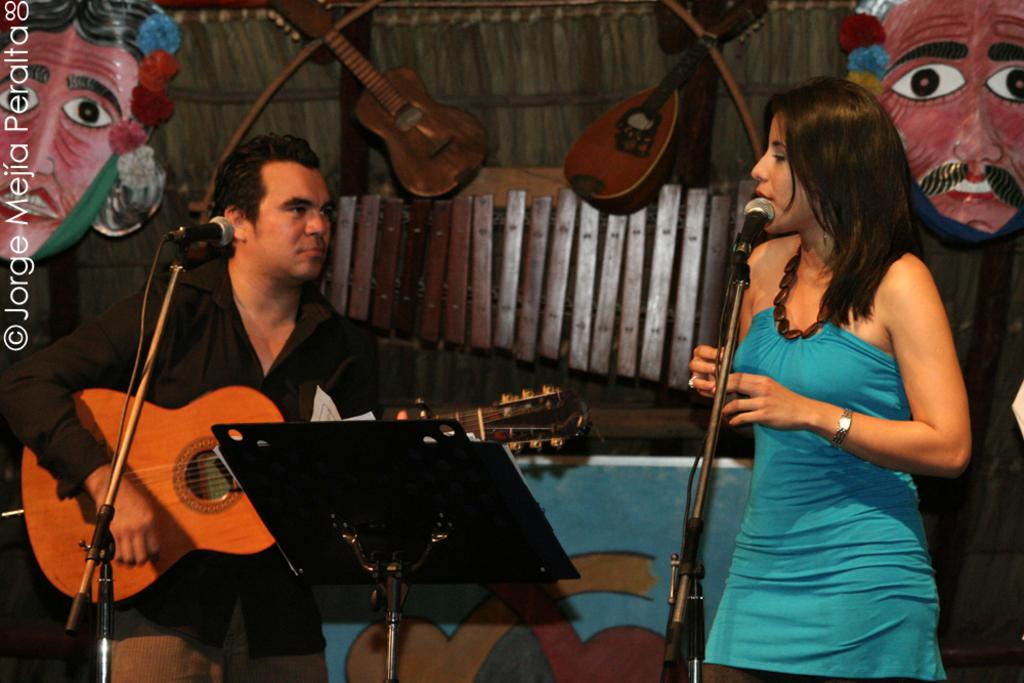What is the person in the image holding? The person is holding a guitar. Who else is present in the image? There is a woman in the image. What is the woman doing in the image? The woman is standing. What object is in front of the woman? There is a microphone with a stand in front of the woman. What type of reaction can be seen on the tongue of the person in the image? There is no tongue visible in the image, and therefore no reaction can be observed. 